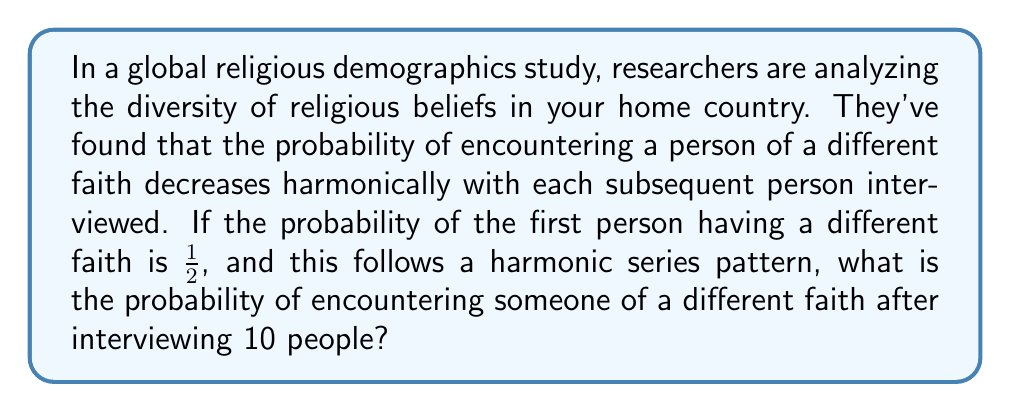Show me your answer to this math problem. Let's approach this step-by-step:

1) The harmonic series is defined as:

   $$ H_n = \sum_{k=1}^n \frac{1}{k} = 1 + \frac{1}{2} + \frac{1}{3} + ... + \frac{1}{n} $$

2) In this case, we start with 1/2 instead of 1, so our series will be:

   $$ \frac{1}{2} + \frac{1}{4} + \frac{1}{6} + \frac{1}{8} + ... + \frac{1}{20} $$

3) This is equivalent to:

   $$ \frac{1}{2} \sum_{k=1}^{10} \frac{1}{k} $$

4) We need to calculate the 10th partial sum of the harmonic series and multiply it by 1/2:

   $$ \frac{1}{2} (H_{10}) $$

5) The exact value of $H_{10}$ is:

   $$ H_{10} = \frac{7381}{2520} \approx 2.9289 $$

6) Therefore, our final calculation is:

   $$ \frac{1}{2} \cdot \frac{7381}{2520} = \frac{7381}{5040} \approx 0.1464 $$

This means the probability of encountering someone of a different faith after interviewing 10 people is approximately 0.1464 or 14.64%.
Answer: $\frac{7381}{5040}$ 